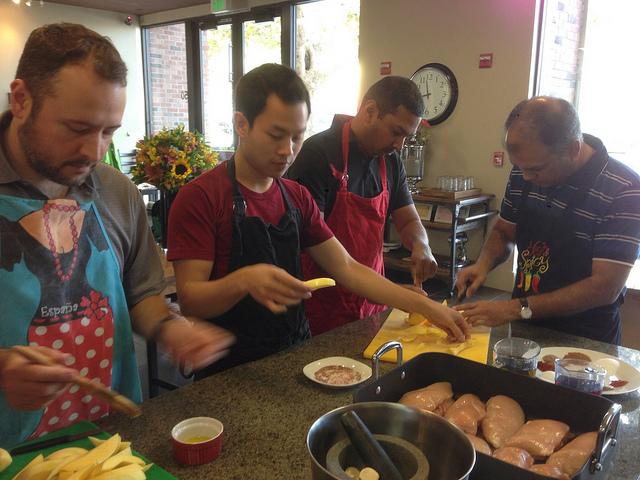What is the raw meat?
Concise answer only. Chicken. Are they working together?
Be succinct. Yes. What are the men doing?
Keep it brief. Cooking. Who has the funniest apron?
Answer briefly. Man on left. How many men at the table?
Quick response, please. 4. Is this someone's house?
Concise answer only. No. Are they participating in a ceremony?
Concise answer only. No. 